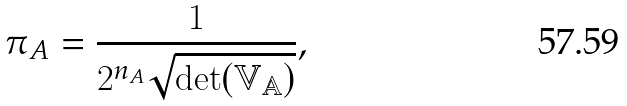Convert formula to latex. <formula><loc_0><loc_0><loc_500><loc_500>\pi _ { A } = \frac { 1 } { 2 ^ { n _ { A } } \sqrt { \det ( \mathbb { V _ { A } } ) } } ,</formula> 